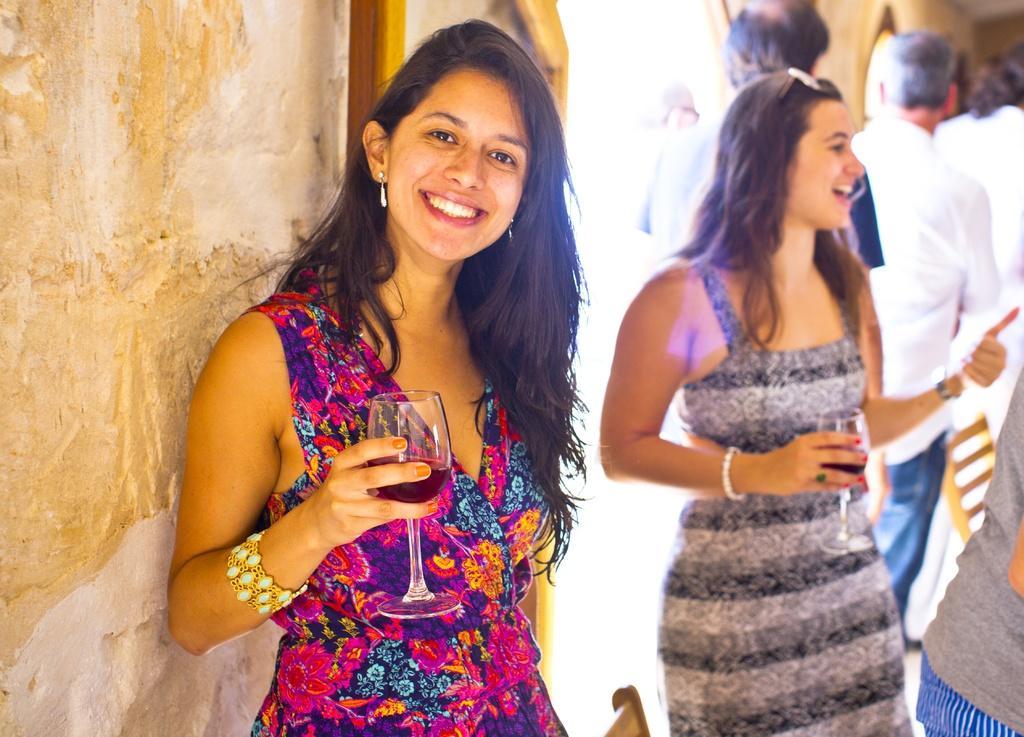Please provide a concise description of this image. In this image I can see some people. On the left side I can see the wall. 